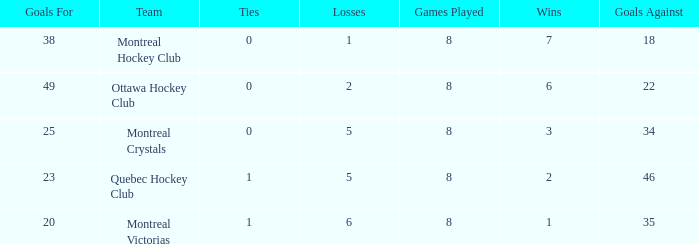What is the average losses when the wins is 3? 5.0. 